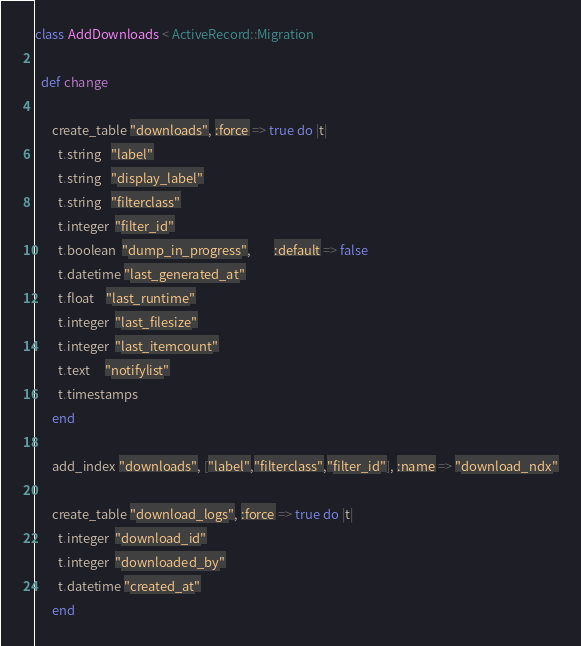Convert code to text. <code><loc_0><loc_0><loc_500><loc_500><_Ruby_>class AddDownloads < ActiveRecord::Migration

  def change

      create_table "downloads", :force => true do |t|
        t.string   "label"
        t.string   "display_label"
        t.string   "filterclass"
        t.integer  "filter_id"
        t.boolean  "dump_in_progress",        :default => false
        t.datetime "last_generated_at"
        t.float    "last_runtime"
        t.integer  "last_filesize"
        t.integer  "last_itemcount"
        t.text     "notifylist"
        t.timestamps
      end

      add_index "downloads", ["label","filterclass","filter_id"], :name => "download_ndx"

      create_table "download_logs", :force => true do |t|
        t.integer  "download_id"
        t.integer  "downloaded_by"
        t.datetime "created_at"
      end
</code> 